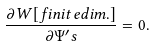<formula> <loc_0><loc_0><loc_500><loc_500>\frac { \partial W [ f i n i t e d i m . ] } { \partial \Psi ^ { \prime } s } = 0 .</formula> 